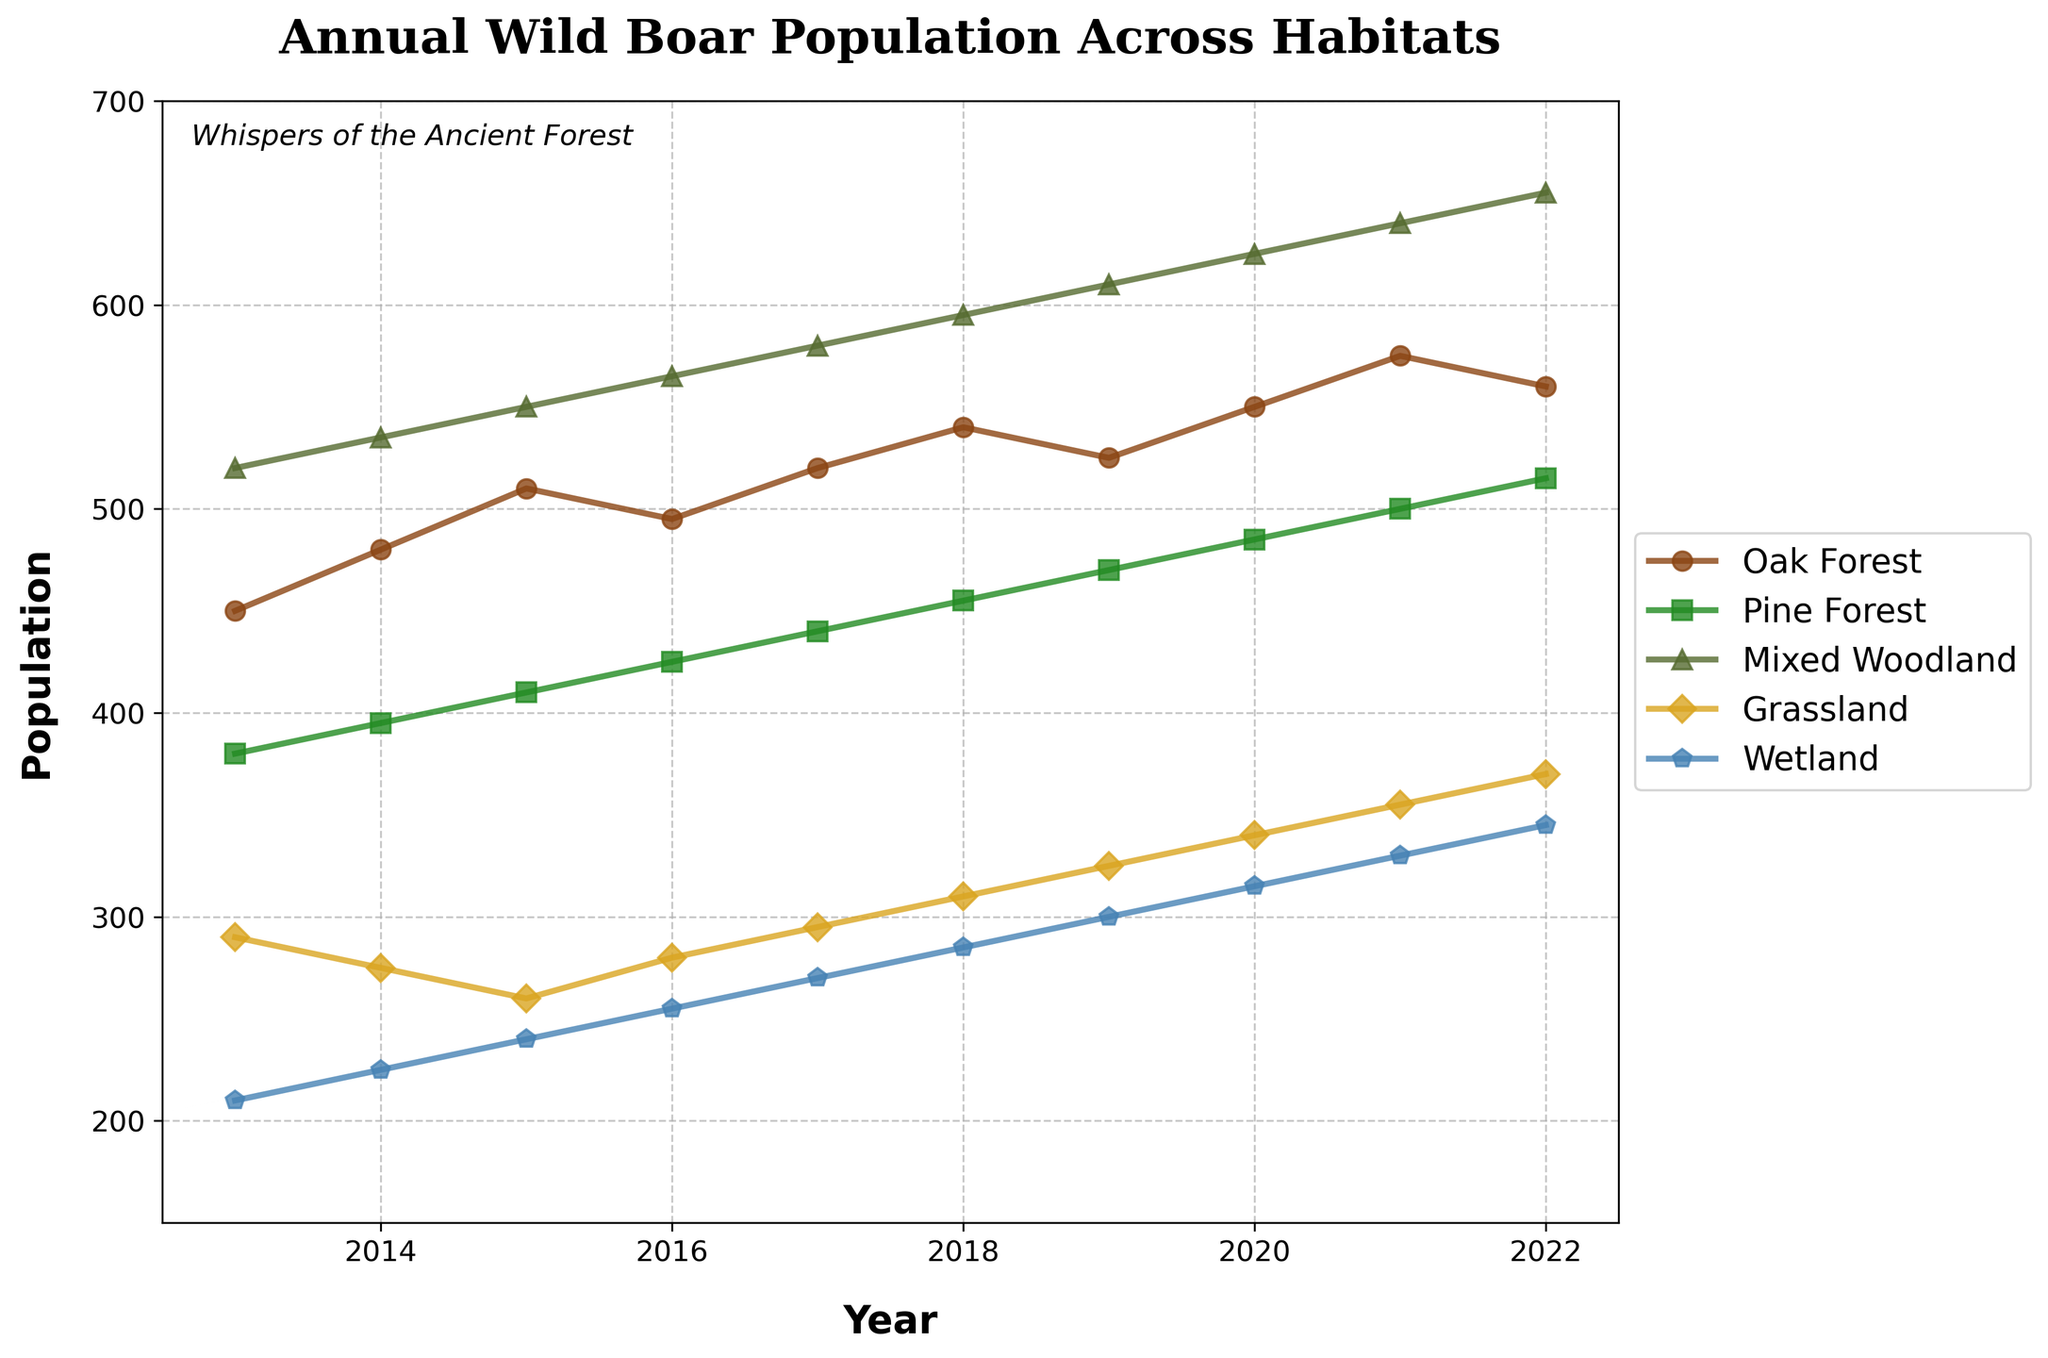What is the overall trend in the wild boar population in "Oak Forest" from 2013 to 2022? To determine the overall trend, observe the pattern of the data points for "Oak Forest" from 2013 to 2022. Note that the population increases from 450 in 2013 to 560 in 2022.
Answer: Increasing Which habitat had the highest wild boar population in 2021? Identify the highest value among all habitats in the year 2021. The populations are Oak Forest: 575, Pine Forest: 500, Mixed Woodland: 640, Grassland: 355, and Wetland: 330.
Answer: Mixed Woodland Between "Pine Forest" and "Grassland," which habitat showed a greater increase in population from 2013 to 2022? Calculate the population difference for each habitat from 2013 to 2022. Pine Forest: 515 - 380 = 135, Grassland: 370 - 290 = 80.
Answer: Pine Forest What was the average wild boar population in "Wetland" over the period from 2013 to 2022? Sum all the Wetland population values from 2013 to 2022 and then divide by the number of years. (210+225+240+255+270+285+300+315+330+345)/10 = 277.5
Answer: 277.5 How did the population in "Mixed Woodland" change from 2015 to 2017? Compare the population values in 2015 and 2017: 550 and 580. The difference is 580 - 550 = 30.
Answer: Increased by 30 Which habitat experienced the smallest change in population from 2013 to 2022? Calculate the population difference for each habitat and identify the smallest. Oak Forest: 560 - 450 = 110, Pine Forest: 515 - 380 = 135, Mixed Woodland: 655 - 520 = 135, Grassland: 370 - 290 = 80, Wetland: 345 - 210 = 135.
Answer: Grassland By how much did the "Oak Forest" population increase from 2018 to 2021? Calculate the population difference between 2018 and 2021: 575 - 540 = 35.
Answer: 35 In which year did "Grassland" have the lowest population? Identify the lowest population value for Grassland across all years and find the corresponding year. The lowest population is 260 in 2015.
Answer: 2015 What is the ratio of the population in "Wetland" to "Grassland" in 2020? Find the population values for "Wetland" and "Grassland" in 2020: 315 and 340. Calculate the ratio: 315/340 = 0.926 (approximately).
Answer: 0.926 